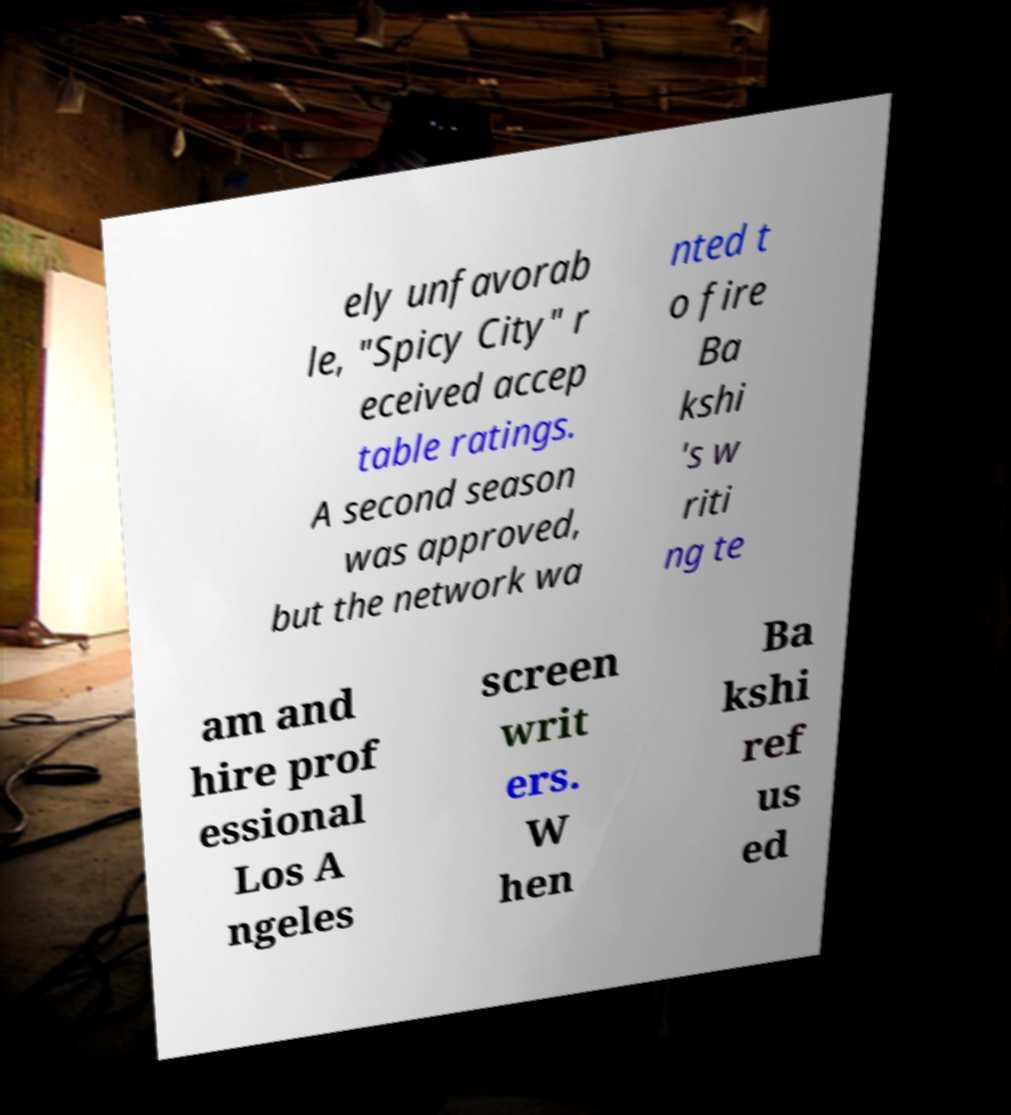Could you extract and type out the text from this image? ely unfavorab le, "Spicy City" r eceived accep table ratings. A second season was approved, but the network wa nted t o fire Ba kshi 's w riti ng te am and hire prof essional Los A ngeles screen writ ers. W hen Ba kshi ref us ed 